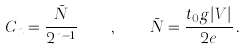<formula> <loc_0><loc_0><loc_500><loc_500>C _ { n } = \frac { \bar { N } } { 2 ^ { n - 1 } } \quad , \quad \bar { N } = \frac { t _ { 0 } g | V | } { 2 e } \, .</formula> 